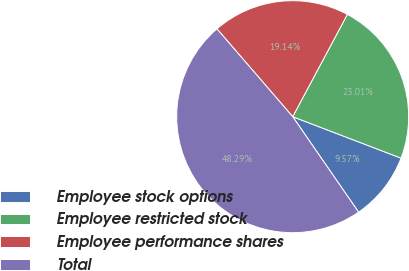Convert chart. <chart><loc_0><loc_0><loc_500><loc_500><pie_chart><fcel>Employee stock options<fcel>Employee restricted stock<fcel>Employee performance shares<fcel>Total<nl><fcel>9.57%<fcel>23.01%<fcel>19.14%<fcel>48.29%<nl></chart> 